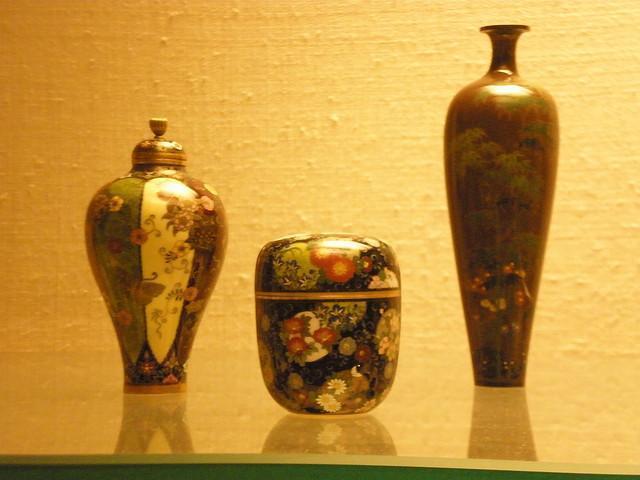How many of the vases have lids?
Give a very brief answer. 2. How many vases are in the photo?
Give a very brief answer. 3. How many people are there?
Give a very brief answer. 0. 